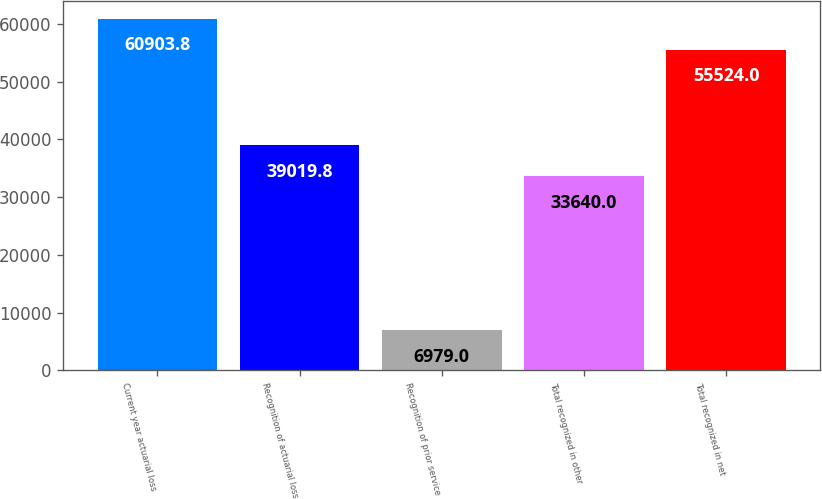<chart> <loc_0><loc_0><loc_500><loc_500><bar_chart><fcel>Current year actuarial loss<fcel>Recognition of actuarial loss<fcel>Recognition of prior service<fcel>Total recognized in other<fcel>Total recognized in net<nl><fcel>60903.8<fcel>39019.8<fcel>6979<fcel>33640<fcel>55524<nl></chart> 